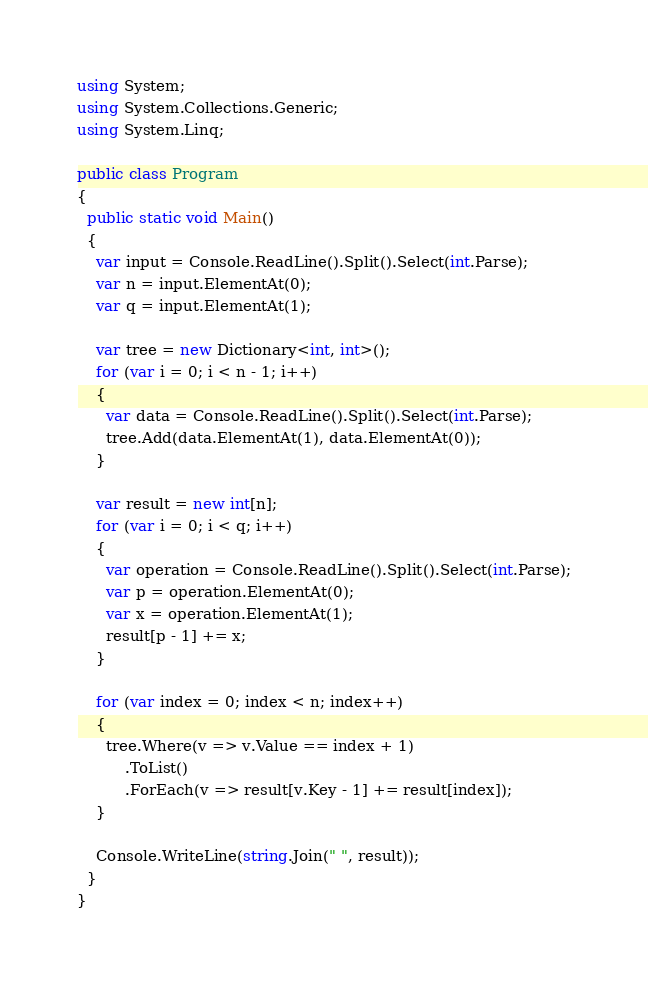<code> <loc_0><loc_0><loc_500><loc_500><_C#_>using System;
using System.Collections.Generic;
using System.Linq;
 
public class Program
{
  public static void Main()
  {
    var input = Console.ReadLine().Split().Select(int.Parse);
    var n = input.ElementAt(0);
    var q = input.ElementAt(1);
 
    var tree = new Dictionary<int, int>();
    for (var i = 0; i < n - 1; i++)
    {
      var data = Console.ReadLine().Split().Select(int.Parse);
      tree.Add(data.ElementAt(1), data.ElementAt(0));
    }
 
    var result = new int[n];
    for (var i = 0; i < q; i++)
    {
      var operation = Console.ReadLine().Split().Select(int.Parse);
      var p = operation.ElementAt(0);
      var x = operation.ElementAt(1);
      result[p - 1] += x;
    }

    for (var index = 0; index < n; index++)
    {
      tree.Where(v => v.Value == index + 1)
          .ToList()
          .ForEach(v => result[v.Key - 1] += result[index]);
    }

    Console.WriteLine(string.Join(" ", result));
  }
}</code> 